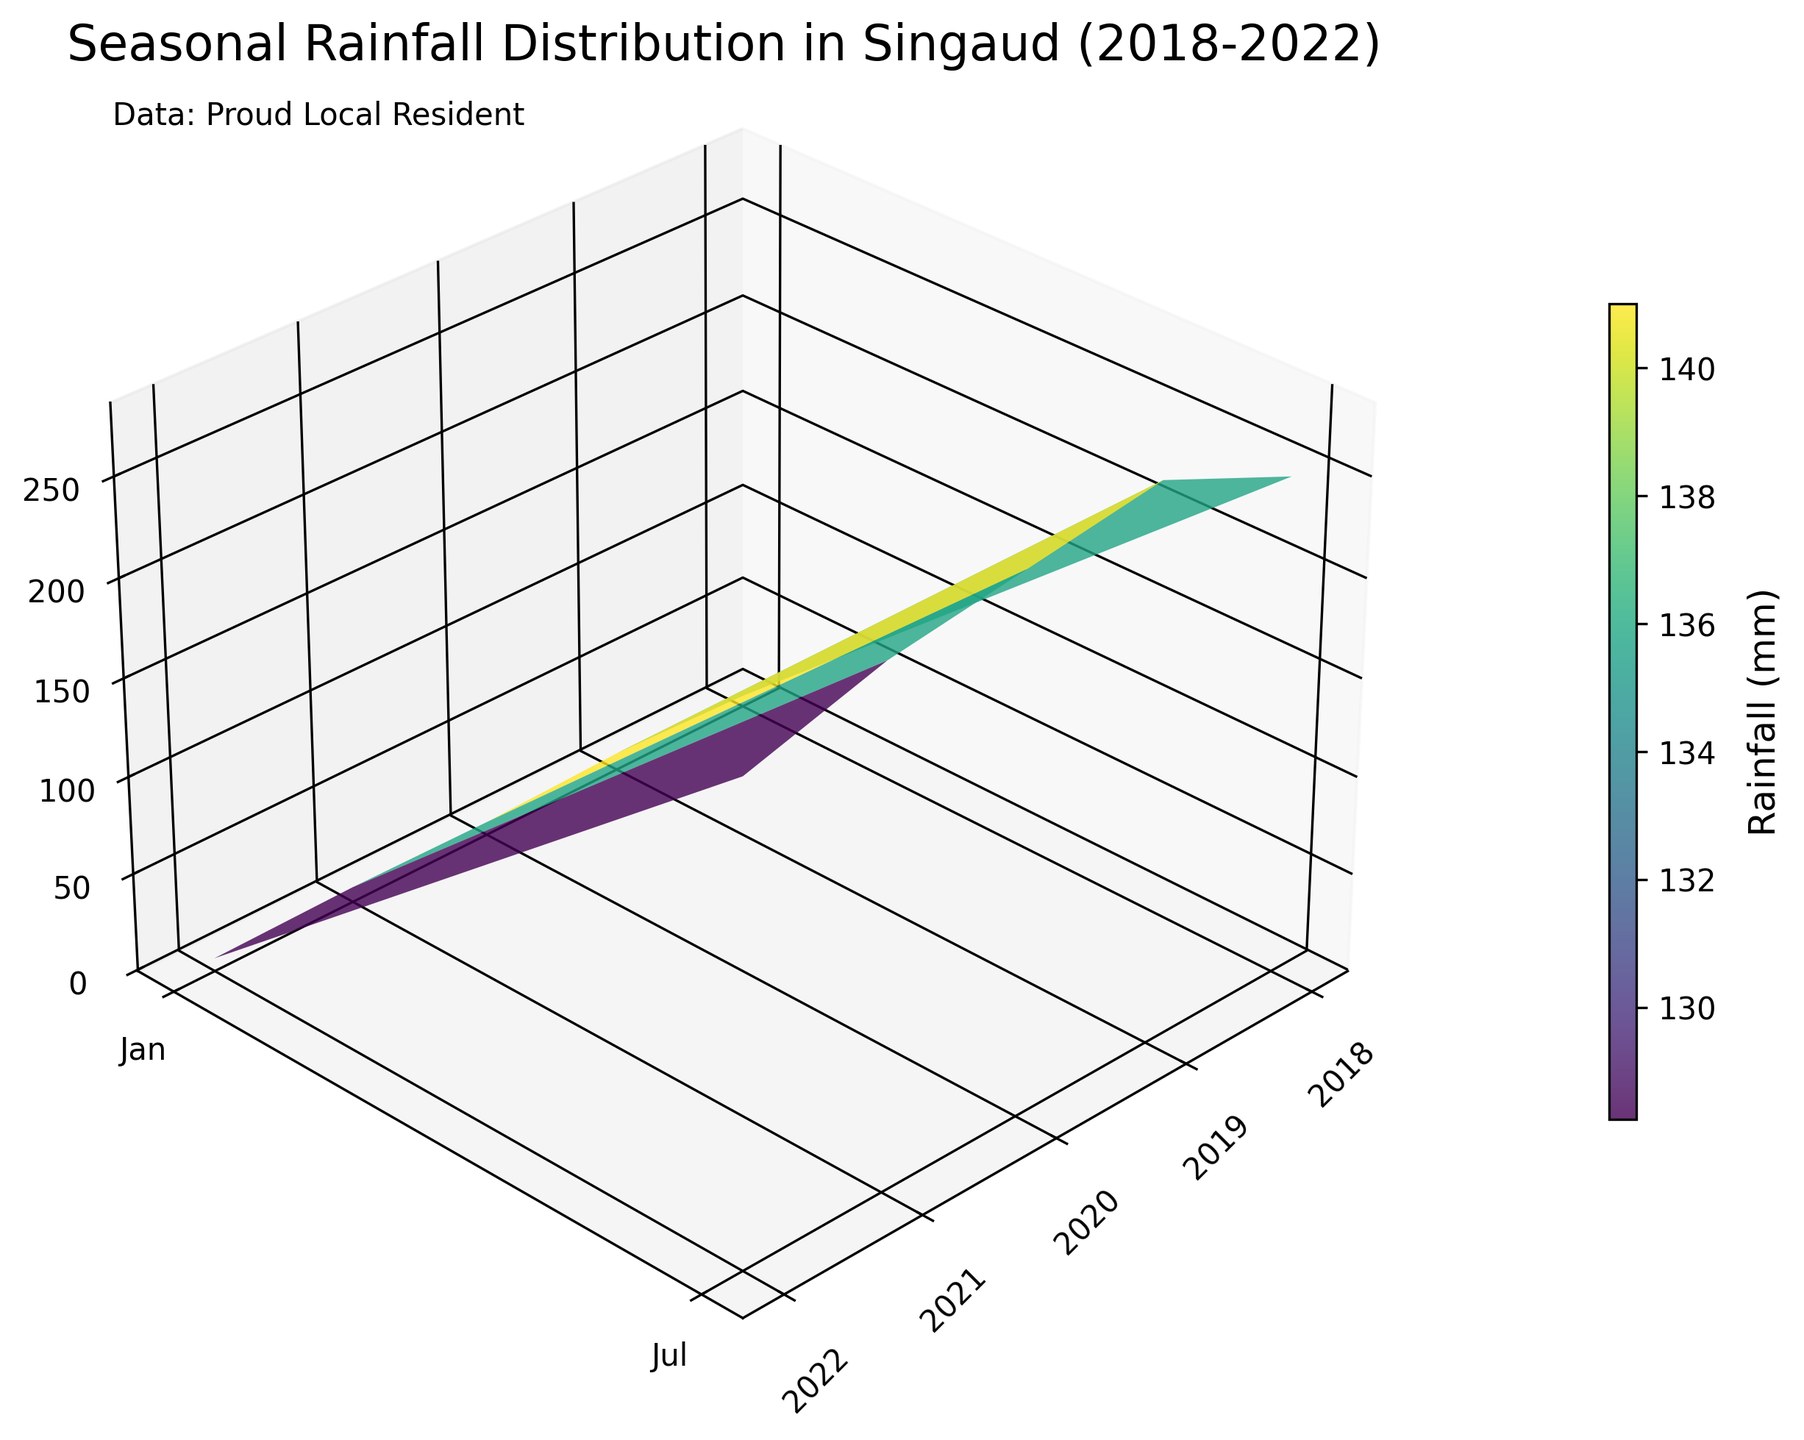How many years of data are displayed in the plot? The x-axis in the plot has ticks that represent each year. By counting the number of unique year labels on the x-axis, we can determine the number of years of data displayed.
Answer: 5 Which month shows the highest rainfall in Singaud? The highest points on the z-axis for Singaud would indicate the maximum rainfall. By analyzing the surface plot, July clearly shows the highest peaks compared to other months.
Answer: July What is the rainfall value for Singaud in January 2020? The January 2020 value can be found on the plot by locating the corresponding position (0, 2) on the x and y axes and then observing the z-axis value.
Answer: 6 mm Compare the rainfall in Singaud for January 2018 and January 2022. Which one is higher? We need to locate the z-axis values for January 2018 and January 2022 on the plot. By examining the surface plot, January 2018 has a higher peak than January 2022.
Answer: January 2018 What is the average rainfall in Singaud over the five January months displayed? We get the January values for each year (5, 8, 6, 7, 6) from the plot and calculate the average: (5 + 8 + 6 + 7 + 6) / 5 = 32 / 5 = 6.4 mm.
Answer: 6.4 mm What trend can you observe in the rainfall pattern of Singaud during the July months over the years? By examining the surface plot for July months, we can see an overall decreasing trend in rainfall values from 2018 to 2022.
Answer: Decreasing Between January 2018 and July 2018, by how much does the rainfall increase in Singaud? By finding the value for January 2018 (5 mm) and July 2018 (250 mm) on the plot and calculating the difference: 250 mm - 5 mm = 245 mm.
Answer: 245 mm Which year recorded the highest overall rainfall in the July months? Comparing the peaks of the July months for each year on the surface plot, 2019 shows the highest peak for July, indicating it had the most rainfall.
Answer: 2019 Compare the rainfall in Singaud for July 2018 and July 2020. Which year had more rainfall? By analyzing the surface plot, the peak for July 2018 is slightly lower than that for July 2020, indicating more rainfall in July 2020.
Answer: July 2020 